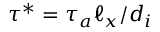<formula> <loc_0><loc_0><loc_500><loc_500>\tau ^ { * } = \tau _ { a } \ell _ { x } / d _ { i }</formula> 